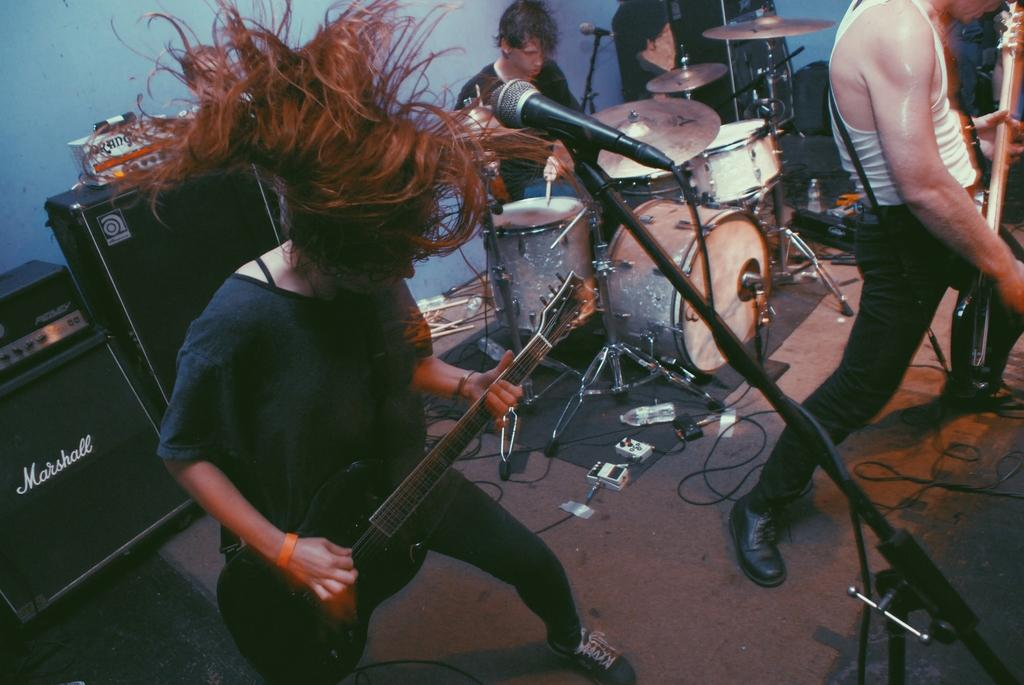What are the people in the image doing? The people in the image are playing musical instruments. What device is present for amplifying sound? There are speakers in the image. What is the purpose of the mic in the image? The mic is present for capturing and transmitting sound, likely for the musicians to be heard. Where is the bomb located in the image? There is no bomb present in the image. Can you describe the father in the image? There is no mention of a father or any individuals in the image, only people playing musical instruments. 